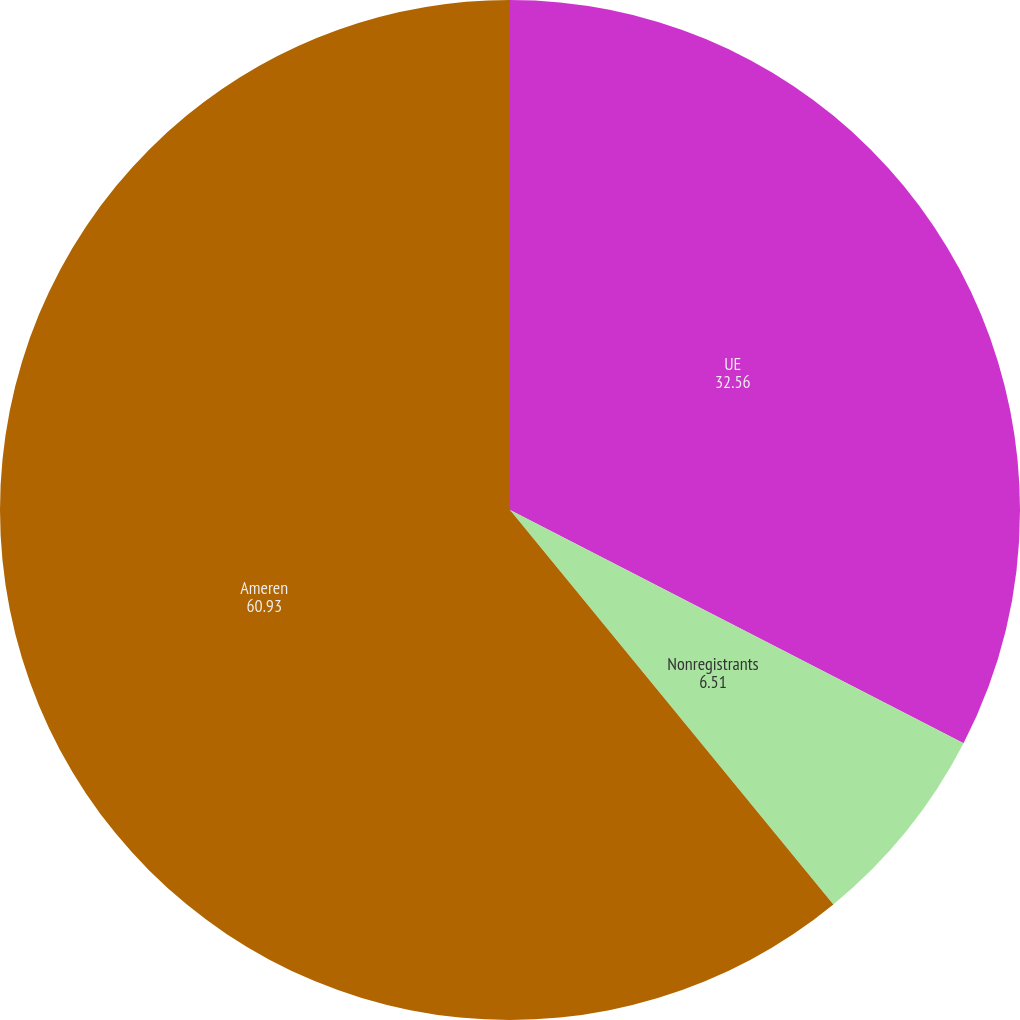Convert chart to OTSL. <chart><loc_0><loc_0><loc_500><loc_500><pie_chart><fcel>UE<fcel>Nonregistrants<fcel>Ameren<nl><fcel>32.56%<fcel>6.51%<fcel>60.93%<nl></chart> 